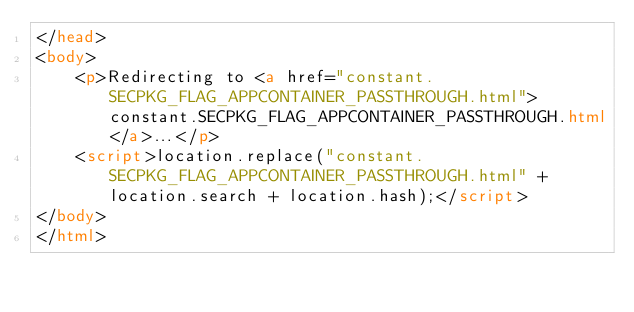Convert code to text. <code><loc_0><loc_0><loc_500><loc_500><_HTML_></head>
<body>
    <p>Redirecting to <a href="constant.SECPKG_FLAG_APPCONTAINER_PASSTHROUGH.html">constant.SECPKG_FLAG_APPCONTAINER_PASSTHROUGH.html</a>...</p>
    <script>location.replace("constant.SECPKG_FLAG_APPCONTAINER_PASSTHROUGH.html" + location.search + location.hash);</script>
</body>
</html></code> 